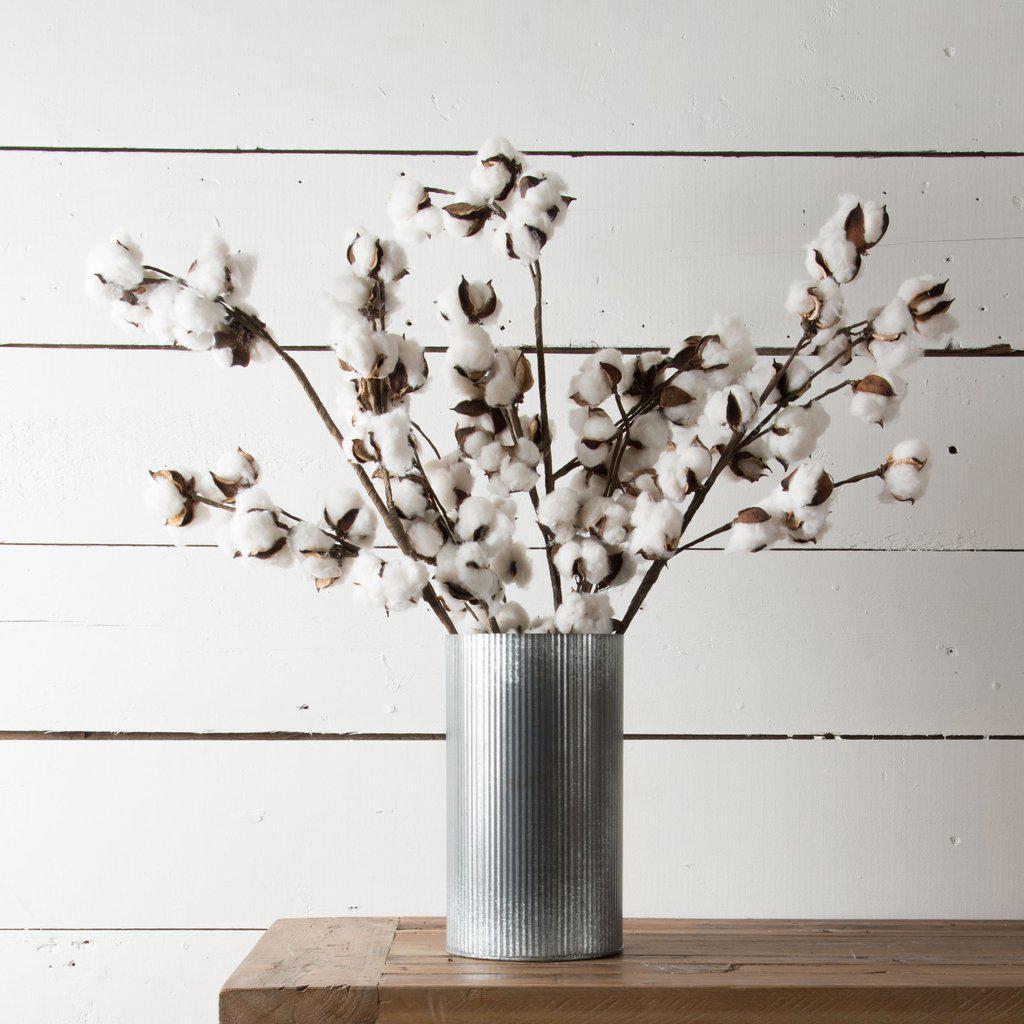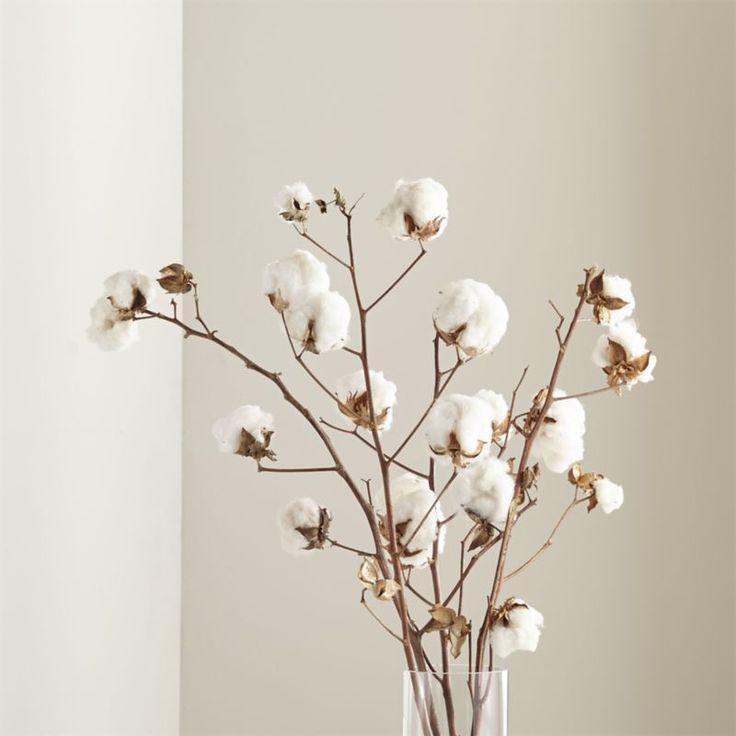The first image is the image on the left, the second image is the image on the right. For the images displayed, is the sentence "The image on the left contains white flowers in a vase." factually correct? Answer yes or no. Yes. 